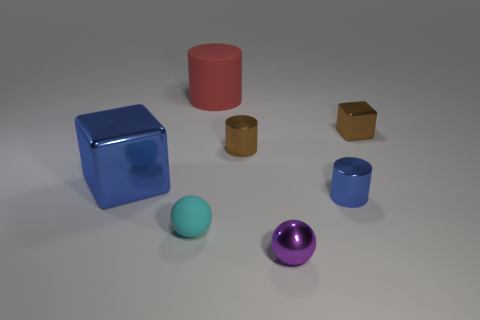There is a small object that is the same color as the large metallic object; what is its material? metal 